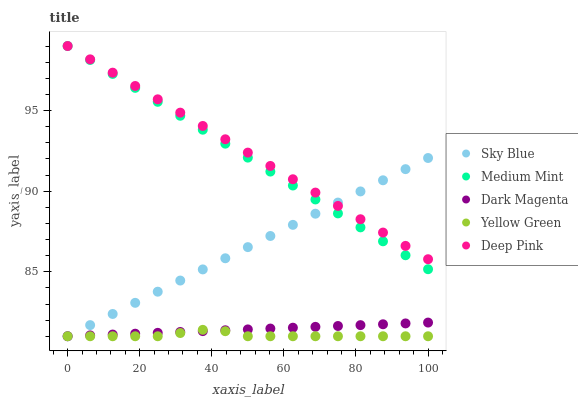Does Yellow Green have the minimum area under the curve?
Answer yes or no. Yes. Does Deep Pink have the maximum area under the curve?
Answer yes or no. Yes. Does Sky Blue have the minimum area under the curve?
Answer yes or no. No. Does Sky Blue have the maximum area under the curve?
Answer yes or no. No. Is Dark Magenta the smoothest?
Answer yes or no. Yes. Is Yellow Green the roughest?
Answer yes or no. Yes. Is Sky Blue the smoothest?
Answer yes or no. No. Is Sky Blue the roughest?
Answer yes or no. No. Does Sky Blue have the lowest value?
Answer yes or no. Yes. Does Deep Pink have the lowest value?
Answer yes or no. No. Does Deep Pink have the highest value?
Answer yes or no. Yes. Does Sky Blue have the highest value?
Answer yes or no. No. Is Yellow Green less than Deep Pink?
Answer yes or no. Yes. Is Medium Mint greater than Yellow Green?
Answer yes or no. Yes. Does Sky Blue intersect Yellow Green?
Answer yes or no. Yes. Is Sky Blue less than Yellow Green?
Answer yes or no. No. Is Sky Blue greater than Yellow Green?
Answer yes or no. No. Does Yellow Green intersect Deep Pink?
Answer yes or no. No. 